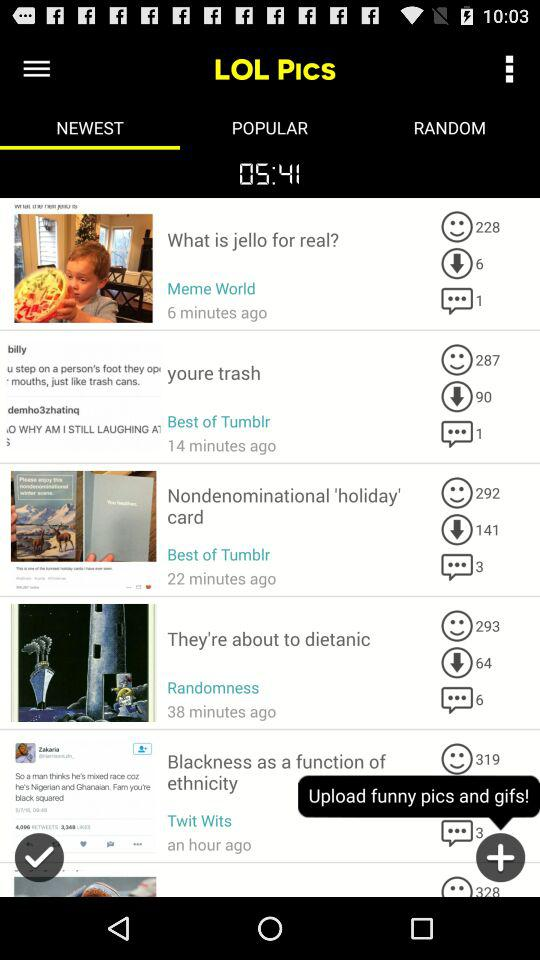What is the time? The time is 05:41. 